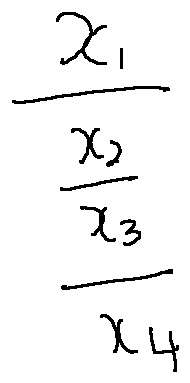Convert formula to latex. <formula><loc_0><loc_0><loc_500><loc_500>\frac { x _ { 1 } } { \frac { x _ { 2 } } { \frac { x _ { 3 } } { x _ { 4 } } } }</formula> 